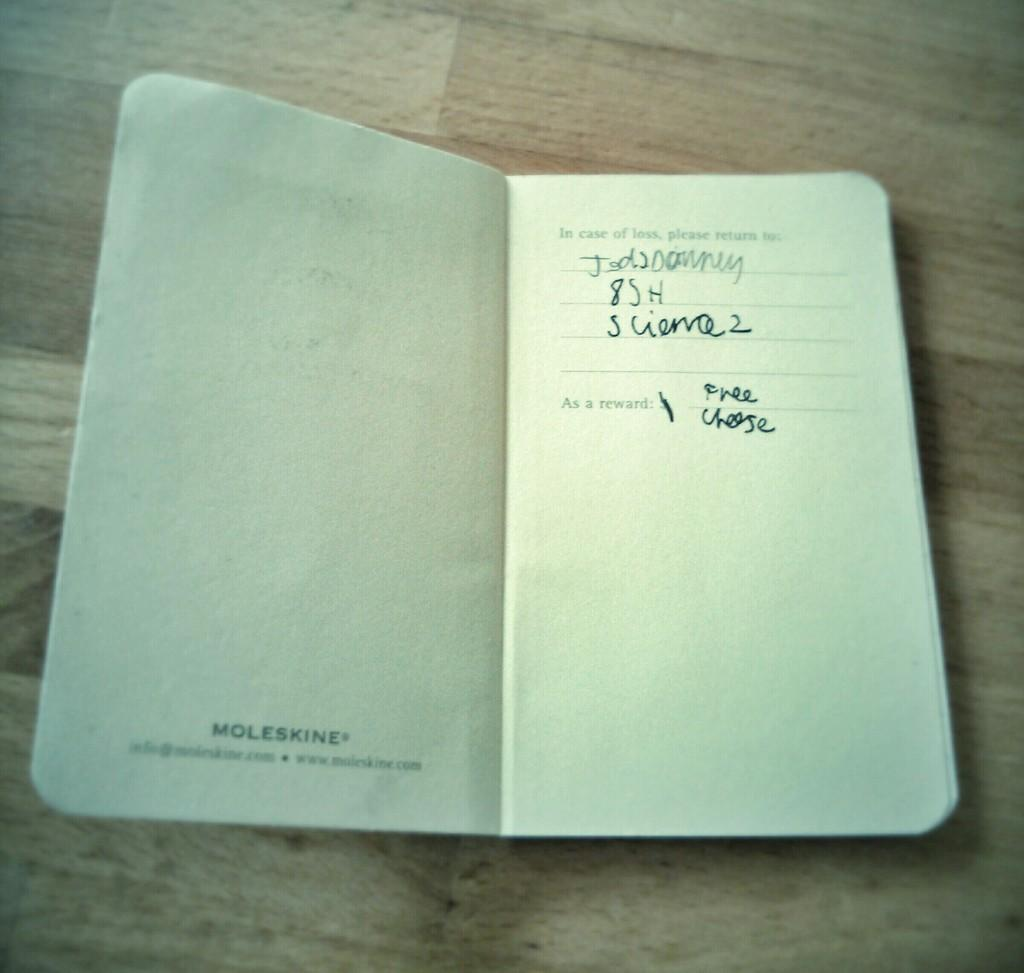Provide a one-sentence caption for the provided image. An open diary made by Moleskine on a wooden table. 